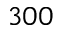Convert formula to latex. <formula><loc_0><loc_0><loc_500><loc_500>3 0 0</formula> 